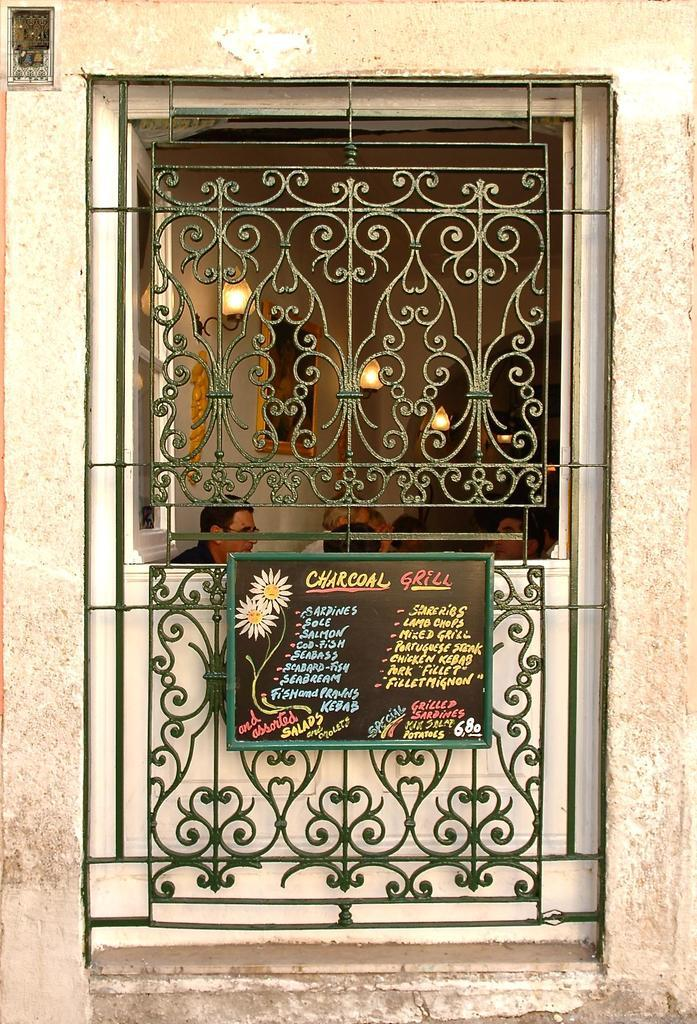What is the main feature in the center of the image? There is a window with a grill in the center of the image. What is written or displayed on the board in the image? There is a board with text in the image. What can be seen in the background of the image? There are people and lights in the background of the image. How many brothers are depicted in the image? There is no mention of brothers in the image, so we cannot determine their presence or number. 